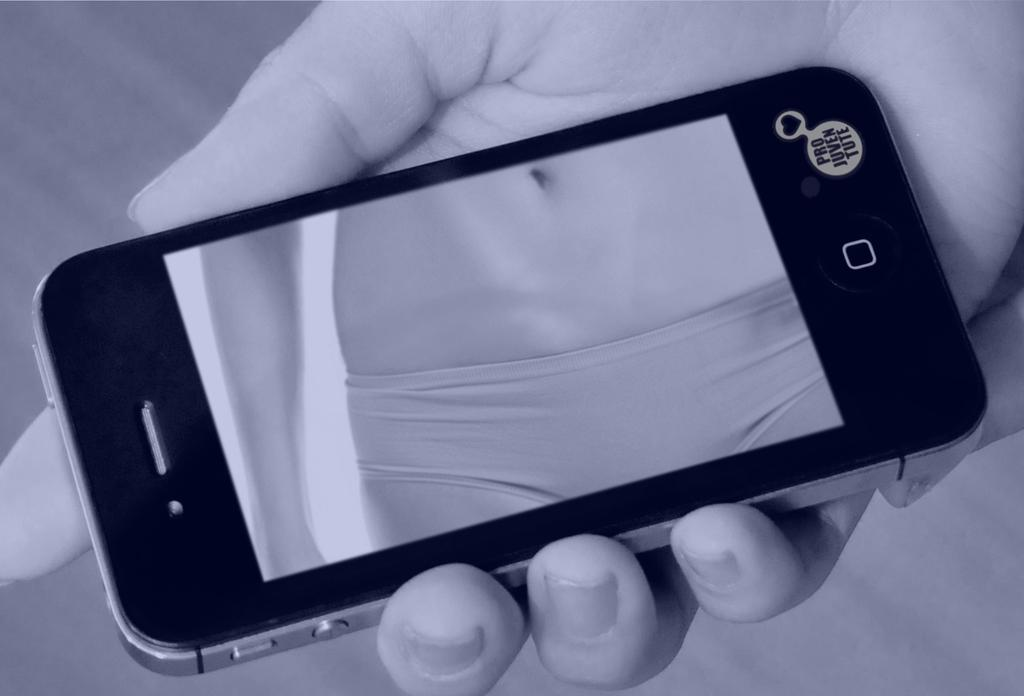What object is visible in the image that people commonly use for communication? There is a mobile phone in the image. Where is the mobile phone located in the image? The mobile phone is on a person's hand. How many oranges are being used to play a game of catch in the image? There are no oranges present in the image, nor is there any game of catch being played. 